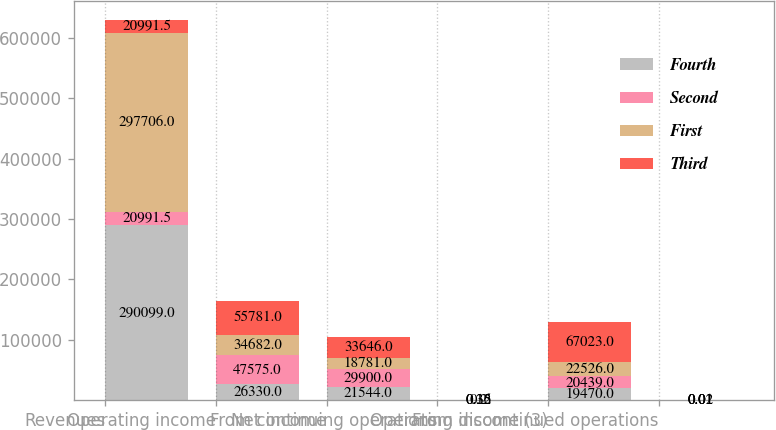Convert chart to OTSL. <chart><loc_0><loc_0><loc_500><loc_500><stacked_bar_chart><ecel><fcel>Revenues<fcel>Operating income<fcel>Net income<fcel>From continuing operations<fcel>Operating income (3)<fcel>From discontinued operations<nl><fcel>Fourth<fcel>290099<fcel>26330<fcel>21544<fcel>0.15<fcel>19470<fcel>0.01<nl><fcel>Second<fcel>20991.5<fcel>47575<fcel>29900<fcel>0.32<fcel>20439<fcel>0.02<nl><fcel>First<fcel>297706<fcel>34682<fcel>18781<fcel>0.2<fcel>22526<fcel>0.01<nl><fcel>Third<fcel>20991.5<fcel>55781<fcel>33646<fcel>0.36<fcel>67023<fcel>0.01<nl></chart> 